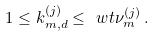Convert formula to latex. <formula><loc_0><loc_0><loc_500><loc_500>1 \leq k _ { m , d } ^ { ( j ) } \leq \ w t { \nu } _ { m } ^ { ( j ) } \, .</formula> 